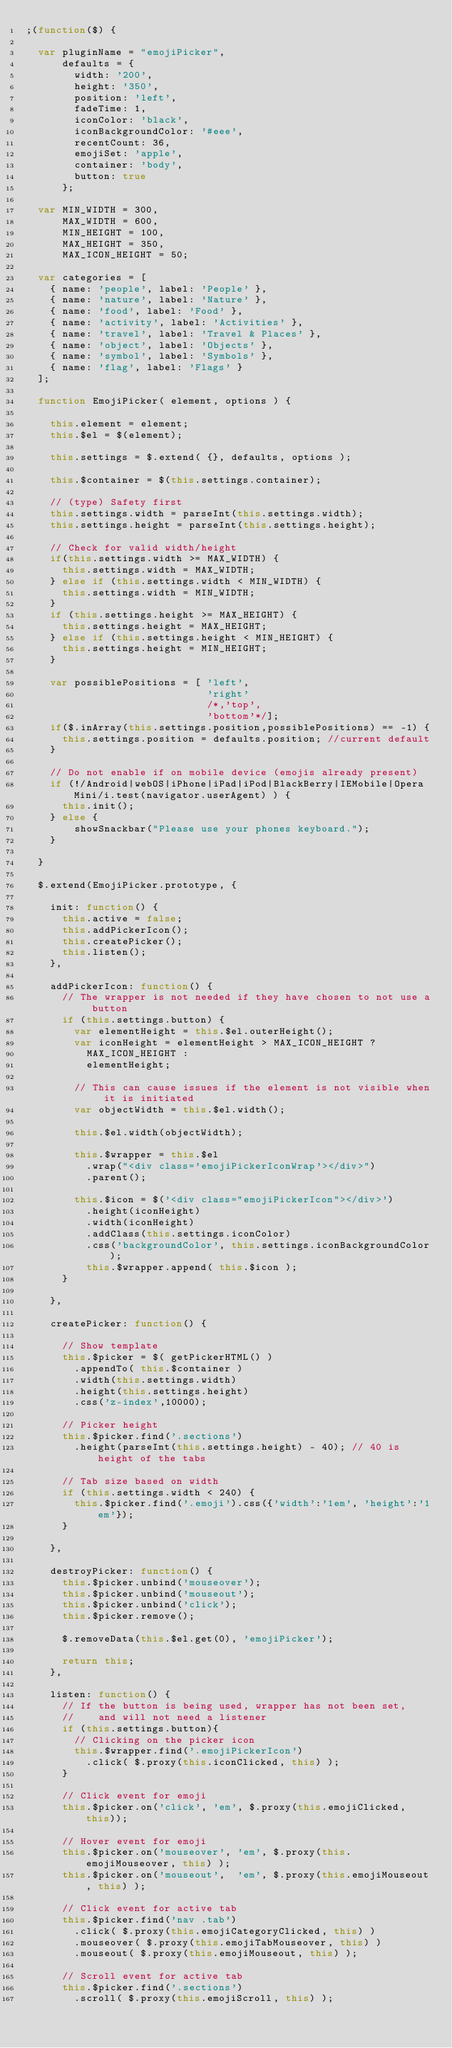<code> <loc_0><loc_0><loc_500><loc_500><_JavaScript_>;(function($) {

  var pluginName = "emojiPicker",
      defaults = {
        width: '200',
        height: '350',
        position: 'left',
        fadeTime: 1,
        iconColor: 'black',
        iconBackgroundColor: '#eee',
        recentCount: 36,
        emojiSet: 'apple',
        container: 'body',
        button: true
      };

  var MIN_WIDTH = 300,
      MAX_WIDTH = 600,
      MIN_HEIGHT = 100,
      MAX_HEIGHT = 350,
      MAX_ICON_HEIGHT = 50;

  var categories = [
    { name: 'people', label: 'People' },
    { name: 'nature', label: 'Nature' },
    { name: 'food', label: 'Food' },
    { name: 'activity', label: 'Activities' },
    { name: 'travel', label: 'Travel & Places' },
    { name: 'object', label: 'Objects' },
    { name: 'symbol', label: 'Symbols' },
    { name: 'flag', label: 'Flags' }
  ];

  function EmojiPicker( element, options ) {

    this.element = element;
    this.$el = $(element);

    this.settings = $.extend( {}, defaults, options );

    this.$container = $(this.settings.container);

    // (type) Safety first
    this.settings.width = parseInt(this.settings.width);
    this.settings.height = parseInt(this.settings.height);

    // Check for valid width/height
    if(this.settings.width >= MAX_WIDTH) {
      this.settings.width = MAX_WIDTH;
    } else if (this.settings.width < MIN_WIDTH) {
      this.settings.width = MIN_WIDTH;
    }
    if (this.settings.height >= MAX_HEIGHT) {
      this.settings.height = MAX_HEIGHT;
    } else if (this.settings.height < MIN_HEIGHT) {
      this.settings.height = MIN_HEIGHT;
    }

    var possiblePositions = [ 'left',
                              'right'
                              /*,'top',
                              'bottom'*/];
    if($.inArray(this.settings.position,possiblePositions) == -1) {
      this.settings.position = defaults.position; //current default
    }

    // Do not enable if on mobile device (emojis already present)
    if (!/Android|webOS|iPhone|iPad|iPod|BlackBerry|IEMobile|Opera Mini/i.test(navigator.userAgent) ) {
      this.init();
    } else {
        showSnackbar("Please use your phones keyboard.");
    }

  }

  $.extend(EmojiPicker.prototype, {

    init: function() {
      this.active = false;
      this.addPickerIcon();
      this.createPicker();
      this.listen();
    },

    addPickerIcon: function() {
      // The wrapper is not needed if they have chosen to not use a button
      if (this.settings.button) {
        var elementHeight = this.$el.outerHeight();
        var iconHeight = elementHeight > MAX_ICON_HEIGHT ?
          MAX_ICON_HEIGHT :
          elementHeight;

        // This can cause issues if the element is not visible when it is initiated
        var objectWidth = this.$el.width();

        this.$el.width(objectWidth);

        this.$wrapper = this.$el
          .wrap("<div class='emojiPickerIconWrap'></div>")
          .parent();

        this.$icon = $('<div class="emojiPickerIcon"></div>')
          .height(iconHeight)
          .width(iconHeight)
          .addClass(this.settings.iconColor)
          .css('backgroundColor', this.settings.iconBackgroundColor);
          this.$wrapper.append( this.$icon );
      }

    },

    createPicker: function() {

      // Show template
      this.$picker = $( getPickerHTML() )
        .appendTo( this.$container )
        .width(this.settings.width)
        .height(this.settings.height)
        .css('z-index',10000);

      // Picker height
      this.$picker.find('.sections')
        .height(parseInt(this.settings.height) - 40); // 40 is height of the tabs

      // Tab size based on width
      if (this.settings.width < 240) {
        this.$picker.find('.emoji').css({'width':'1em', 'height':'1em'});
      }

    },

    destroyPicker: function() {
      this.$picker.unbind('mouseover');
      this.$picker.unbind('mouseout');
      this.$picker.unbind('click');
      this.$picker.remove();

      $.removeData(this.$el.get(0), 'emojiPicker');

      return this;
    },

    listen: function() {
      // If the button is being used, wrapper has not been set,
      //    and will not need a listener
      if (this.settings.button){
        // Clicking on the picker icon
        this.$wrapper.find('.emojiPickerIcon')
          .click( $.proxy(this.iconClicked, this) );
      }

      // Click event for emoji
      this.$picker.on('click', 'em', $.proxy(this.emojiClicked, this));

      // Hover event for emoji
      this.$picker.on('mouseover', 'em', $.proxy(this.emojiMouseover, this) );
      this.$picker.on('mouseout',  'em', $.proxy(this.emojiMouseout, this) );

      // Click event for active tab
      this.$picker.find('nav .tab')
        .click( $.proxy(this.emojiCategoryClicked, this) )
        .mouseover( $.proxy(this.emojiTabMouseover, this) )
        .mouseout( $.proxy(this.emojiMouseout, this) );

      // Scroll event for active tab
      this.$picker.find('.sections')
        .scroll( $.proxy(this.emojiScroll, this) );
</code> 